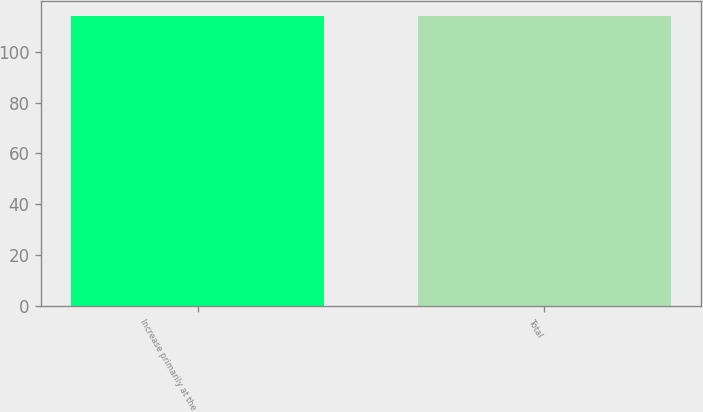Convert chart. <chart><loc_0><loc_0><loc_500><loc_500><bar_chart><fcel>Increase primarily at the<fcel>Total<nl><fcel>114<fcel>114.1<nl></chart> 